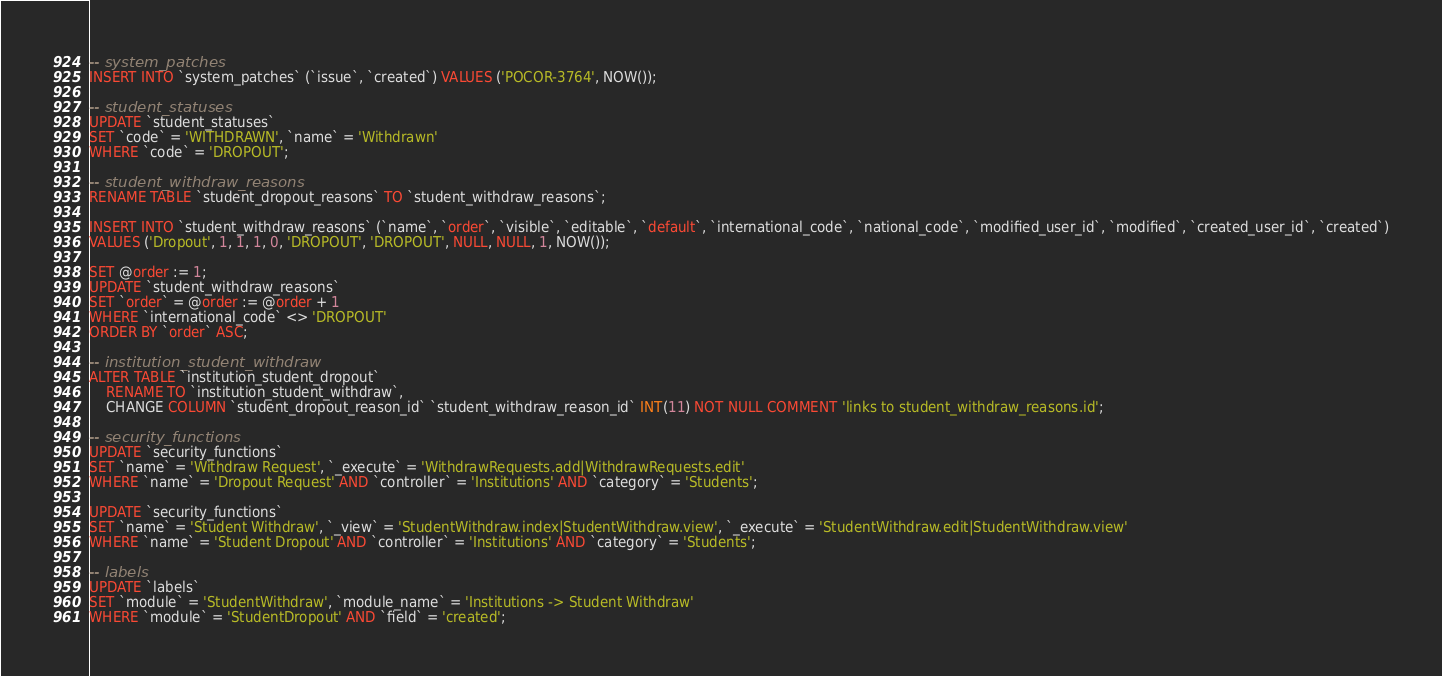Convert code to text. <code><loc_0><loc_0><loc_500><loc_500><_SQL_>-- system_patches
INSERT INTO `system_patches` (`issue`, `created`) VALUES ('POCOR-3764', NOW());

-- student_statuses
UPDATE `student_statuses`
SET `code` = 'WITHDRAWN', `name` = 'Withdrawn'
WHERE `code` = 'DROPOUT';

-- student_withdraw_reasons
RENAME TABLE `student_dropout_reasons` TO `student_withdraw_reasons`;

INSERT INTO `student_withdraw_reasons` (`name`, `order`, `visible`, `editable`, `default`, `international_code`, `national_code`, `modified_user_id`, `modified`, `created_user_id`, `created`)
VALUES ('Dropout', 1, 1, 1, 0, 'DROPOUT', 'DROPOUT', NULL, NULL, 1, NOW());

SET @order := 1;
UPDATE `student_withdraw_reasons`
SET `order` = @order := @order + 1
WHERE `international_code` <> 'DROPOUT'
ORDER BY `order` ASC;

-- institution_student_withdraw
ALTER TABLE `institution_student_dropout`
    RENAME TO `institution_student_withdraw`,
    CHANGE COLUMN `student_dropout_reason_id` `student_withdraw_reason_id` INT(11) NOT NULL COMMENT 'links to student_withdraw_reasons.id';

-- security_functions
UPDATE `security_functions`
SET `name` = 'Withdraw Request', `_execute` = 'WithdrawRequests.add|WithdrawRequests.edit'
WHERE `name` = 'Dropout Request' AND `controller` = 'Institutions' AND `category` = 'Students';

UPDATE `security_functions`
SET `name` = 'Student Withdraw', `_view` = 'StudentWithdraw.index|StudentWithdraw.view', `_execute` = 'StudentWithdraw.edit|StudentWithdraw.view'
WHERE `name` = 'Student Dropout' AND `controller` = 'Institutions' AND `category` = 'Students';

-- labels
UPDATE `labels`
SET `module` = 'StudentWithdraw', `module_name` = 'Institutions -> Student Withdraw'
WHERE `module` = 'StudentDropout' AND `field` = 'created';
</code> 